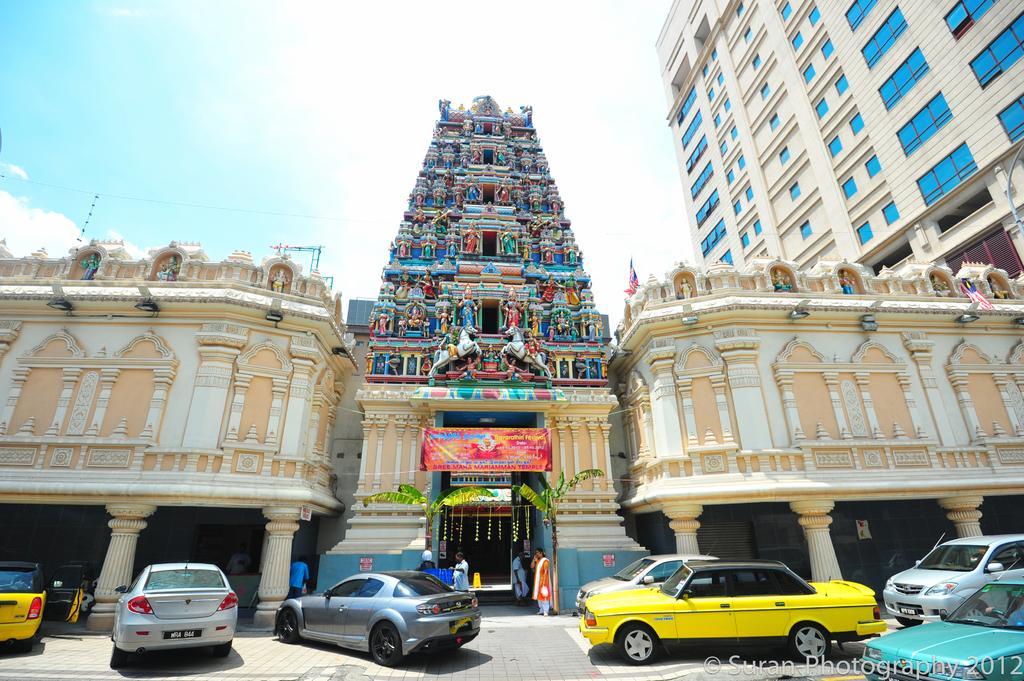Please provide a concise description of this image. In this picture i can see the skyscraper, building and temple. At the bottom i can see many vehicles which is parked in front of the temple. In the bottom right corner there is a watermark. Near to the banana tree we can see some people were standing, beside them there is a banner. In the bottom left corner there is a woman who is standing near to the pillar. At the top i can see the sky and clouds. On the right i can see the pole and flags. In the center i can see the statues on the wall. 